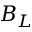Convert formula to latex. <formula><loc_0><loc_0><loc_500><loc_500>B _ { L }</formula> 